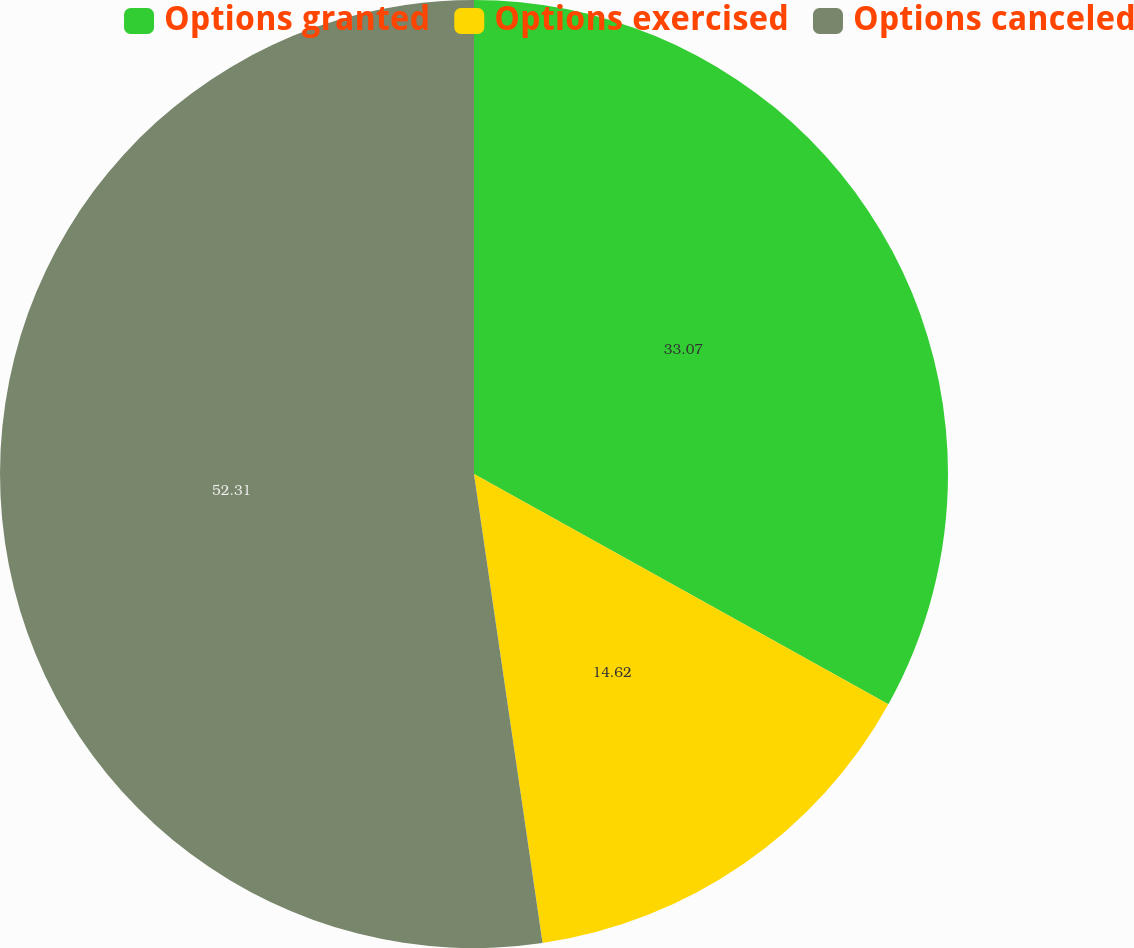<chart> <loc_0><loc_0><loc_500><loc_500><pie_chart><fcel>Options granted<fcel>Options exercised<fcel>Options canceled<nl><fcel>33.07%<fcel>14.62%<fcel>52.31%<nl></chart> 